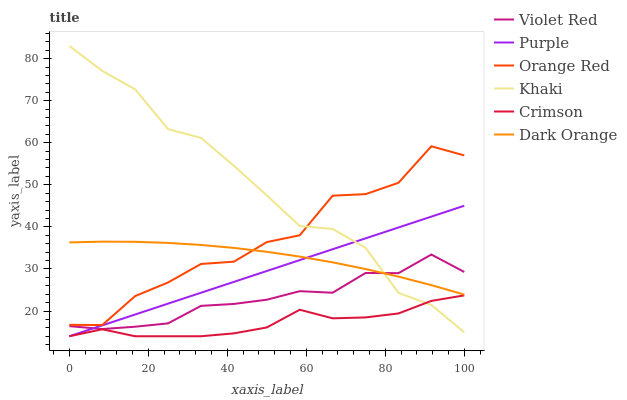Does Violet Red have the minimum area under the curve?
Answer yes or no. No. Does Violet Red have the maximum area under the curve?
Answer yes or no. No. Is Violet Red the smoothest?
Answer yes or no. No. Is Violet Red the roughest?
Answer yes or no. No. Does Violet Red have the lowest value?
Answer yes or no. No. Does Violet Red have the highest value?
Answer yes or no. No. Is Violet Red less than Orange Red?
Answer yes or no. Yes. Is Dark Orange greater than Crimson?
Answer yes or no. Yes. Does Violet Red intersect Orange Red?
Answer yes or no. No. 